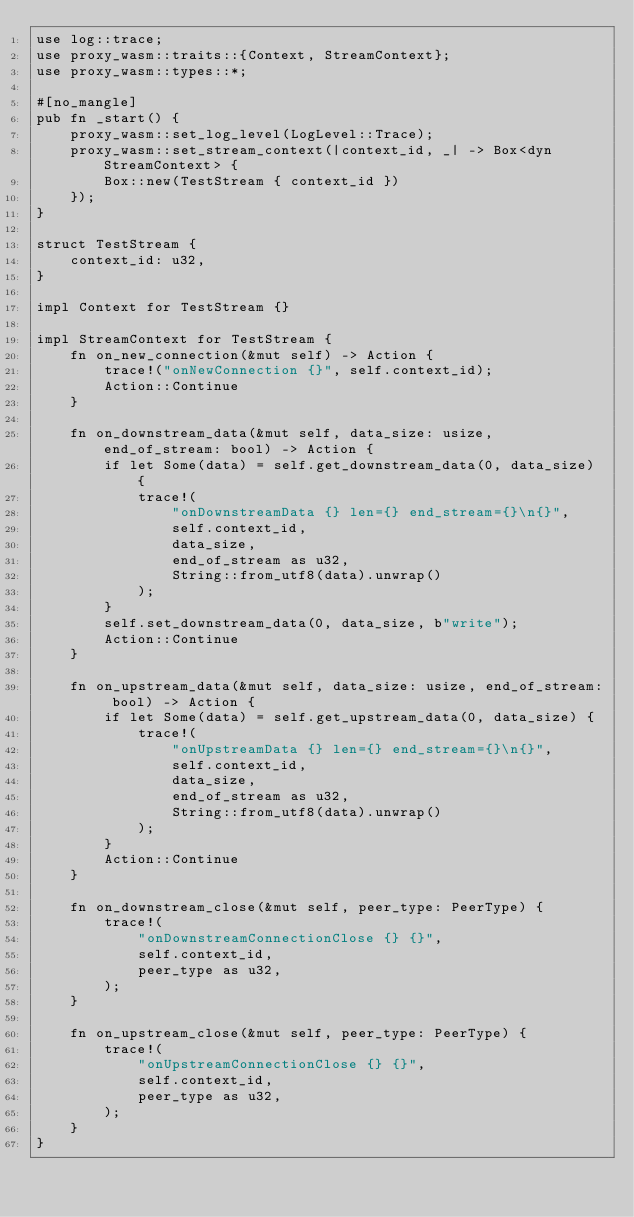<code> <loc_0><loc_0><loc_500><loc_500><_Rust_>use log::trace;
use proxy_wasm::traits::{Context, StreamContext};
use proxy_wasm::types::*;

#[no_mangle]
pub fn _start() {
    proxy_wasm::set_log_level(LogLevel::Trace);
    proxy_wasm::set_stream_context(|context_id, _| -> Box<dyn StreamContext> {
        Box::new(TestStream { context_id })
    });
}

struct TestStream {
    context_id: u32,
}

impl Context for TestStream {}

impl StreamContext for TestStream {
    fn on_new_connection(&mut self) -> Action {
        trace!("onNewConnection {}", self.context_id);
        Action::Continue
    }

    fn on_downstream_data(&mut self, data_size: usize, end_of_stream: bool) -> Action {
        if let Some(data) = self.get_downstream_data(0, data_size) {
            trace!(
                "onDownstreamData {} len={} end_stream={}\n{}",
                self.context_id,
                data_size,
                end_of_stream as u32,
                String::from_utf8(data).unwrap()
            );
        }
        self.set_downstream_data(0, data_size, b"write");
        Action::Continue
    }

    fn on_upstream_data(&mut self, data_size: usize, end_of_stream: bool) -> Action {
        if let Some(data) = self.get_upstream_data(0, data_size) {
            trace!(
                "onUpstreamData {} len={} end_stream={}\n{}",
                self.context_id,
                data_size,
                end_of_stream as u32,
                String::from_utf8(data).unwrap()
            );
        }
        Action::Continue
    }

    fn on_downstream_close(&mut self, peer_type: PeerType) {
        trace!(
            "onDownstreamConnectionClose {} {}",
            self.context_id,
            peer_type as u32,
        );
    }

    fn on_upstream_close(&mut self, peer_type: PeerType) {
        trace!(
            "onUpstreamConnectionClose {} {}",
            self.context_id,
            peer_type as u32,
        );
    }
}
</code> 